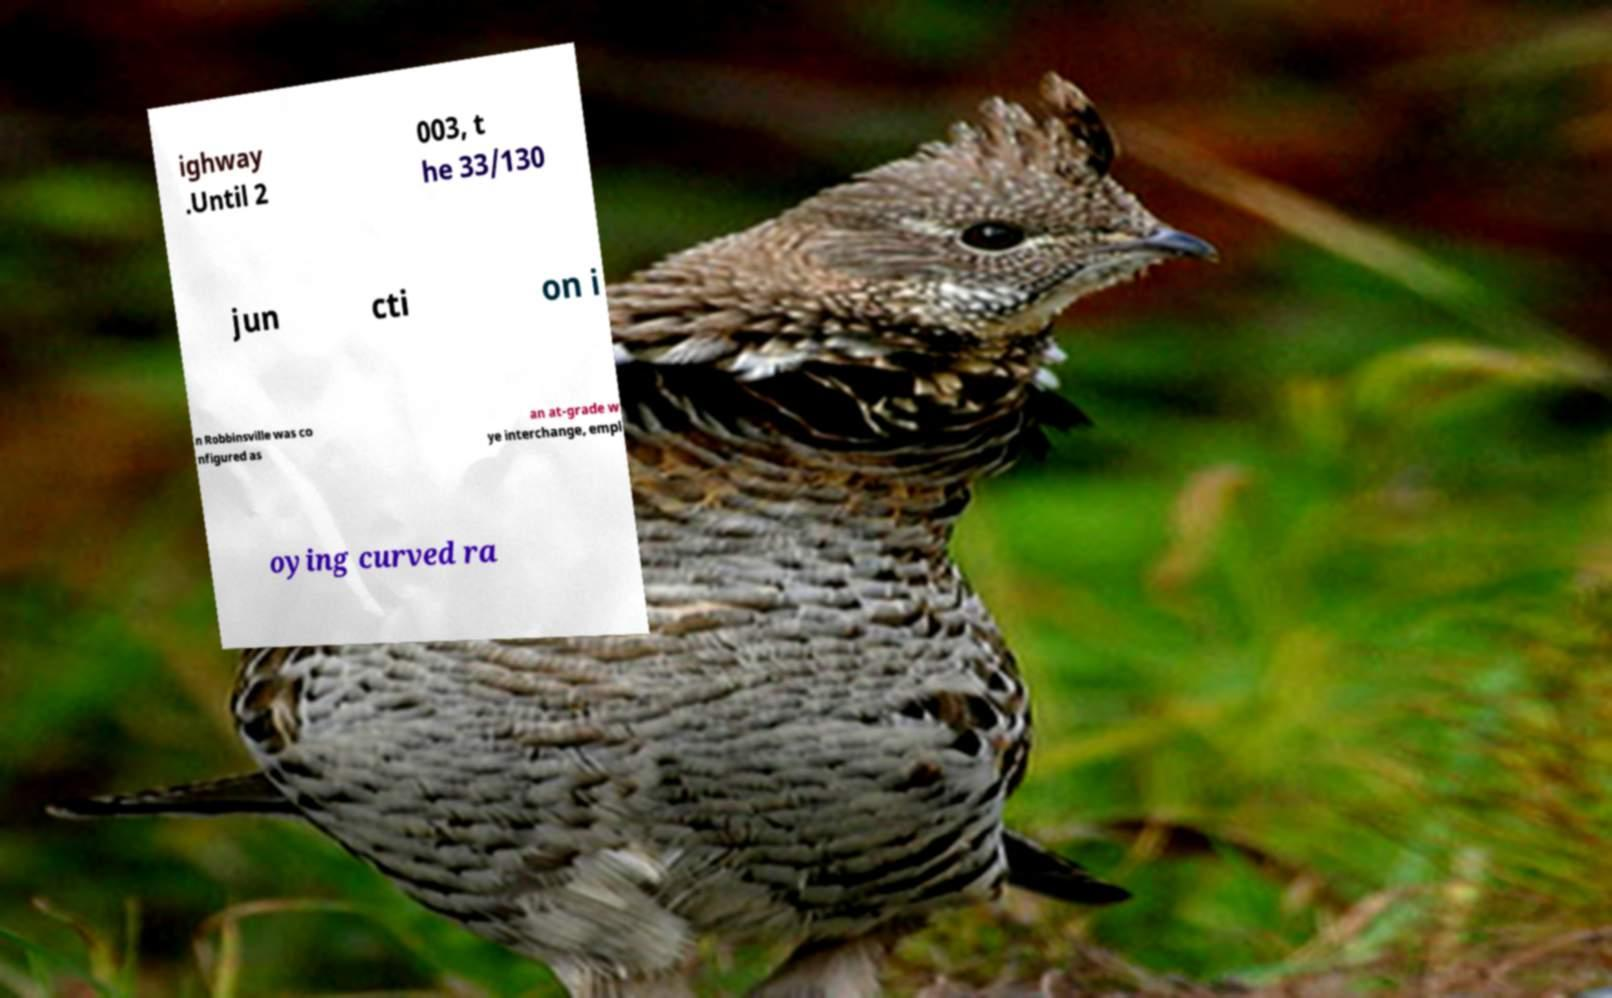For documentation purposes, I need the text within this image transcribed. Could you provide that? ighway .Until 2 003, t he 33/130 jun cti on i n Robbinsville was co nfigured as an at-grade w ye interchange, empl oying curved ra 